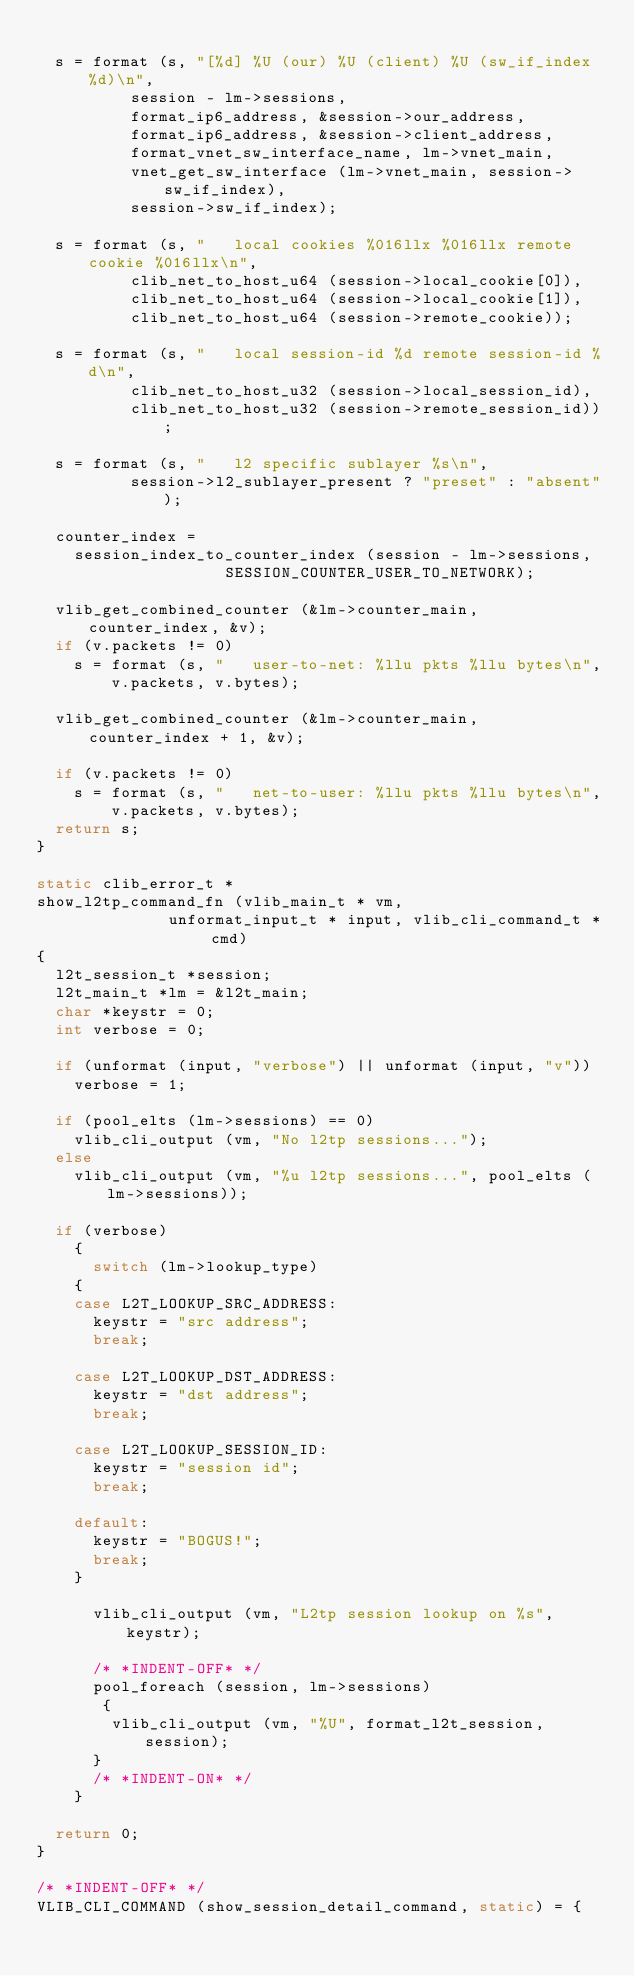Convert code to text. <code><loc_0><loc_0><loc_500><loc_500><_C_>
  s = format (s, "[%d] %U (our) %U (client) %U (sw_if_index %d)\n",
	      session - lm->sessions,
	      format_ip6_address, &session->our_address,
	      format_ip6_address, &session->client_address,
	      format_vnet_sw_interface_name, lm->vnet_main,
	      vnet_get_sw_interface (lm->vnet_main, session->sw_if_index),
	      session->sw_if_index);

  s = format (s, "   local cookies %016llx %016llx remote cookie %016llx\n",
	      clib_net_to_host_u64 (session->local_cookie[0]),
	      clib_net_to_host_u64 (session->local_cookie[1]),
	      clib_net_to_host_u64 (session->remote_cookie));

  s = format (s, "   local session-id %d remote session-id %d\n",
	      clib_net_to_host_u32 (session->local_session_id),
	      clib_net_to_host_u32 (session->remote_session_id));

  s = format (s, "   l2 specific sublayer %s\n",
	      session->l2_sublayer_present ? "preset" : "absent");

  counter_index =
    session_index_to_counter_index (session - lm->sessions,
				    SESSION_COUNTER_USER_TO_NETWORK);

  vlib_get_combined_counter (&lm->counter_main, counter_index, &v);
  if (v.packets != 0)
    s = format (s, "   user-to-net: %llu pkts %llu bytes\n",
		v.packets, v.bytes);

  vlib_get_combined_counter (&lm->counter_main, counter_index + 1, &v);

  if (v.packets != 0)
    s = format (s, "   net-to-user: %llu pkts %llu bytes\n",
		v.packets, v.bytes);
  return s;
}

static clib_error_t *
show_l2tp_command_fn (vlib_main_t * vm,
		      unformat_input_t * input, vlib_cli_command_t * cmd)
{
  l2t_session_t *session;
  l2t_main_t *lm = &l2t_main;
  char *keystr = 0;
  int verbose = 0;

  if (unformat (input, "verbose") || unformat (input, "v"))
    verbose = 1;

  if (pool_elts (lm->sessions) == 0)
    vlib_cli_output (vm, "No l2tp sessions...");
  else
    vlib_cli_output (vm, "%u l2tp sessions...", pool_elts (lm->sessions));

  if (verbose)
    {
      switch (lm->lookup_type)
	{
	case L2T_LOOKUP_SRC_ADDRESS:
	  keystr = "src address";
	  break;

	case L2T_LOOKUP_DST_ADDRESS:
	  keystr = "dst address";
	  break;

	case L2T_LOOKUP_SESSION_ID:
	  keystr = "session id";
	  break;

	default:
	  keystr = "BOGUS!";
	  break;
	}

      vlib_cli_output (vm, "L2tp session lookup on %s", keystr);

      /* *INDENT-OFF* */
      pool_foreach (session, lm->sessions)
       {
        vlib_cli_output (vm, "%U", format_l2t_session, session);
      }
      /* *INDENT-ON* */
    }

  return 0;
}

/* *INDENT-OFF* */
VLIB_CLI_COMMAND (show_session_detail_command, static) = {</code> 